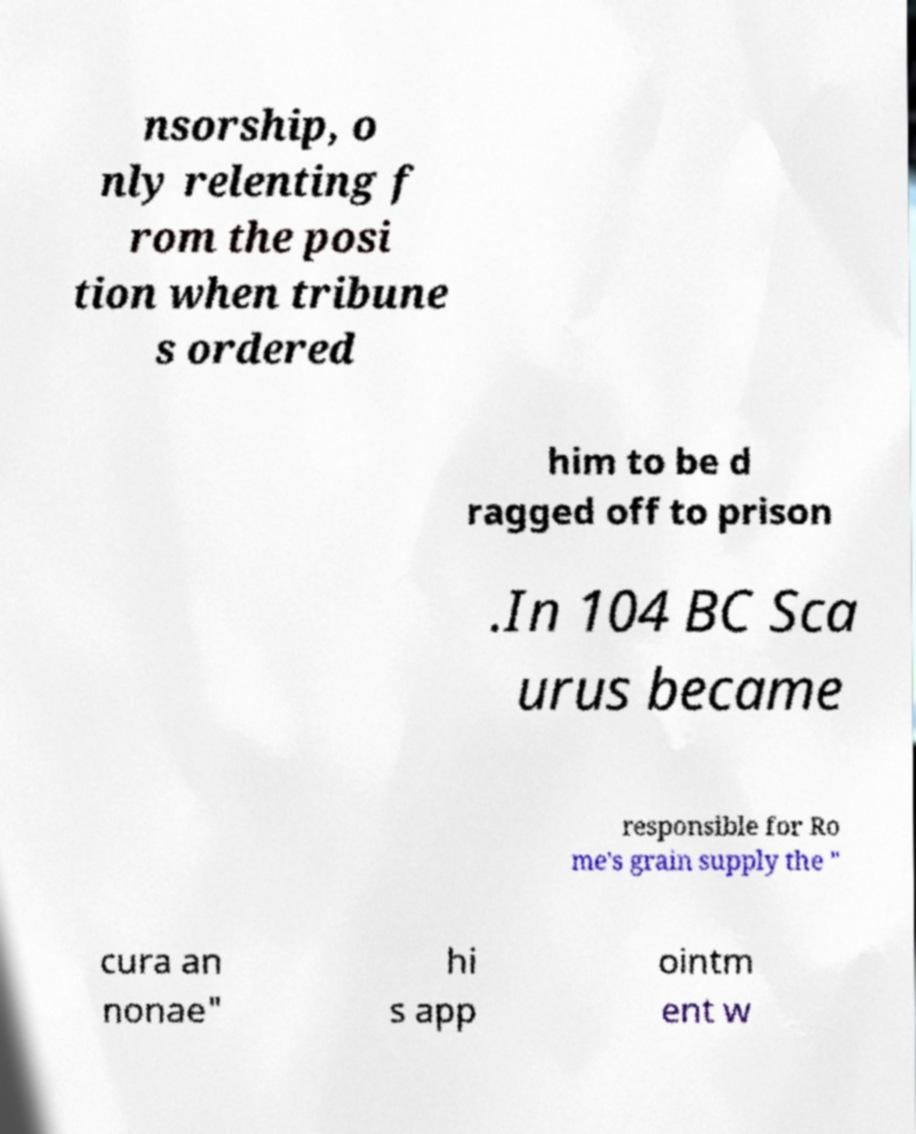I need the written content from this picture converted into text. Can you do that? nsorship, o nly relenting f rom the posi tion when tribune s ordered him to be d ragged off to prison .In 104 BC Sca urus became responsible for Ro me's grain supply the " cura an nonae" hi s app ointm ent w 